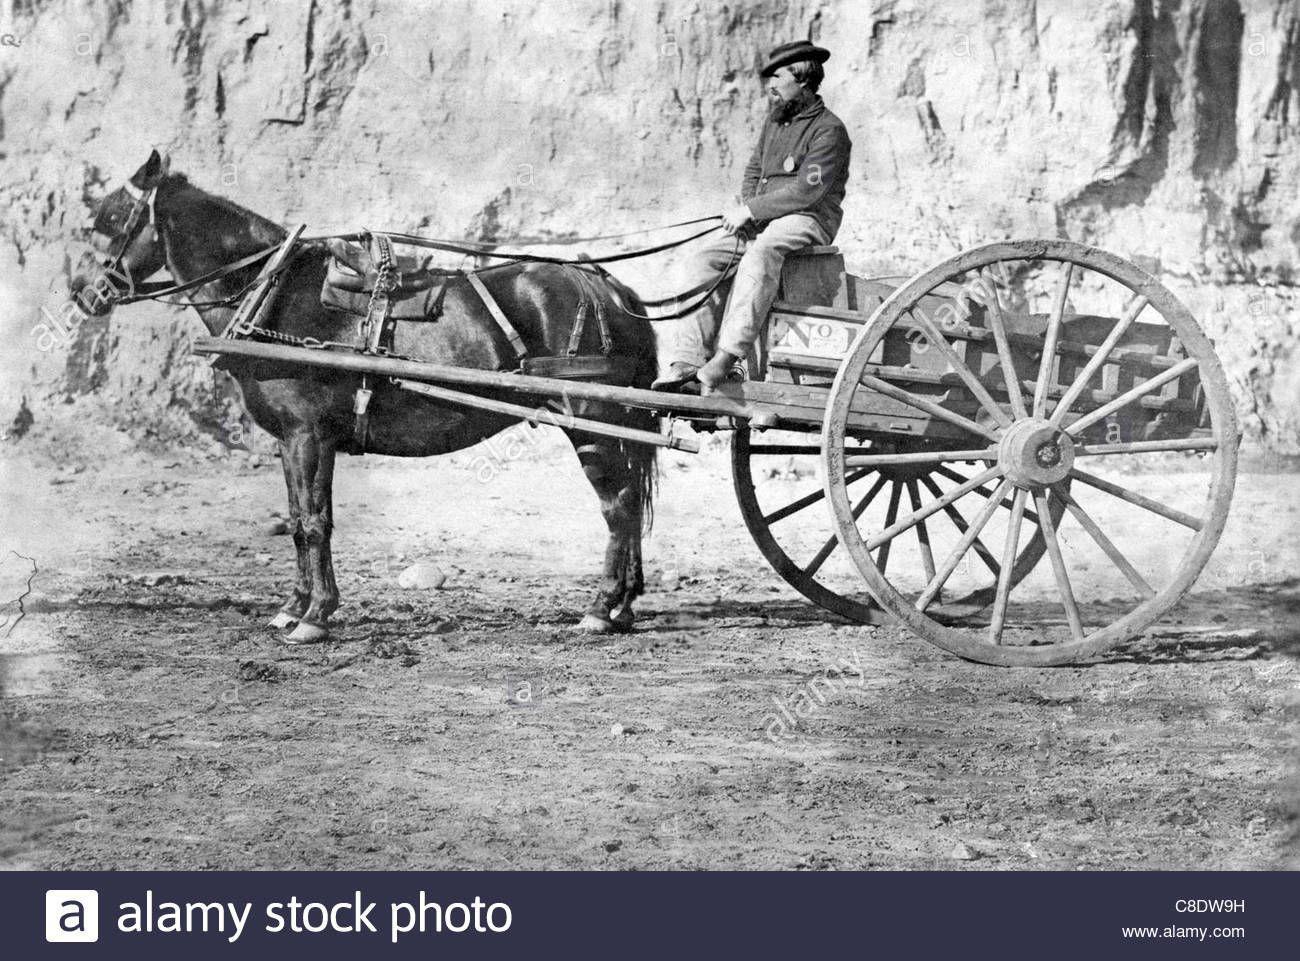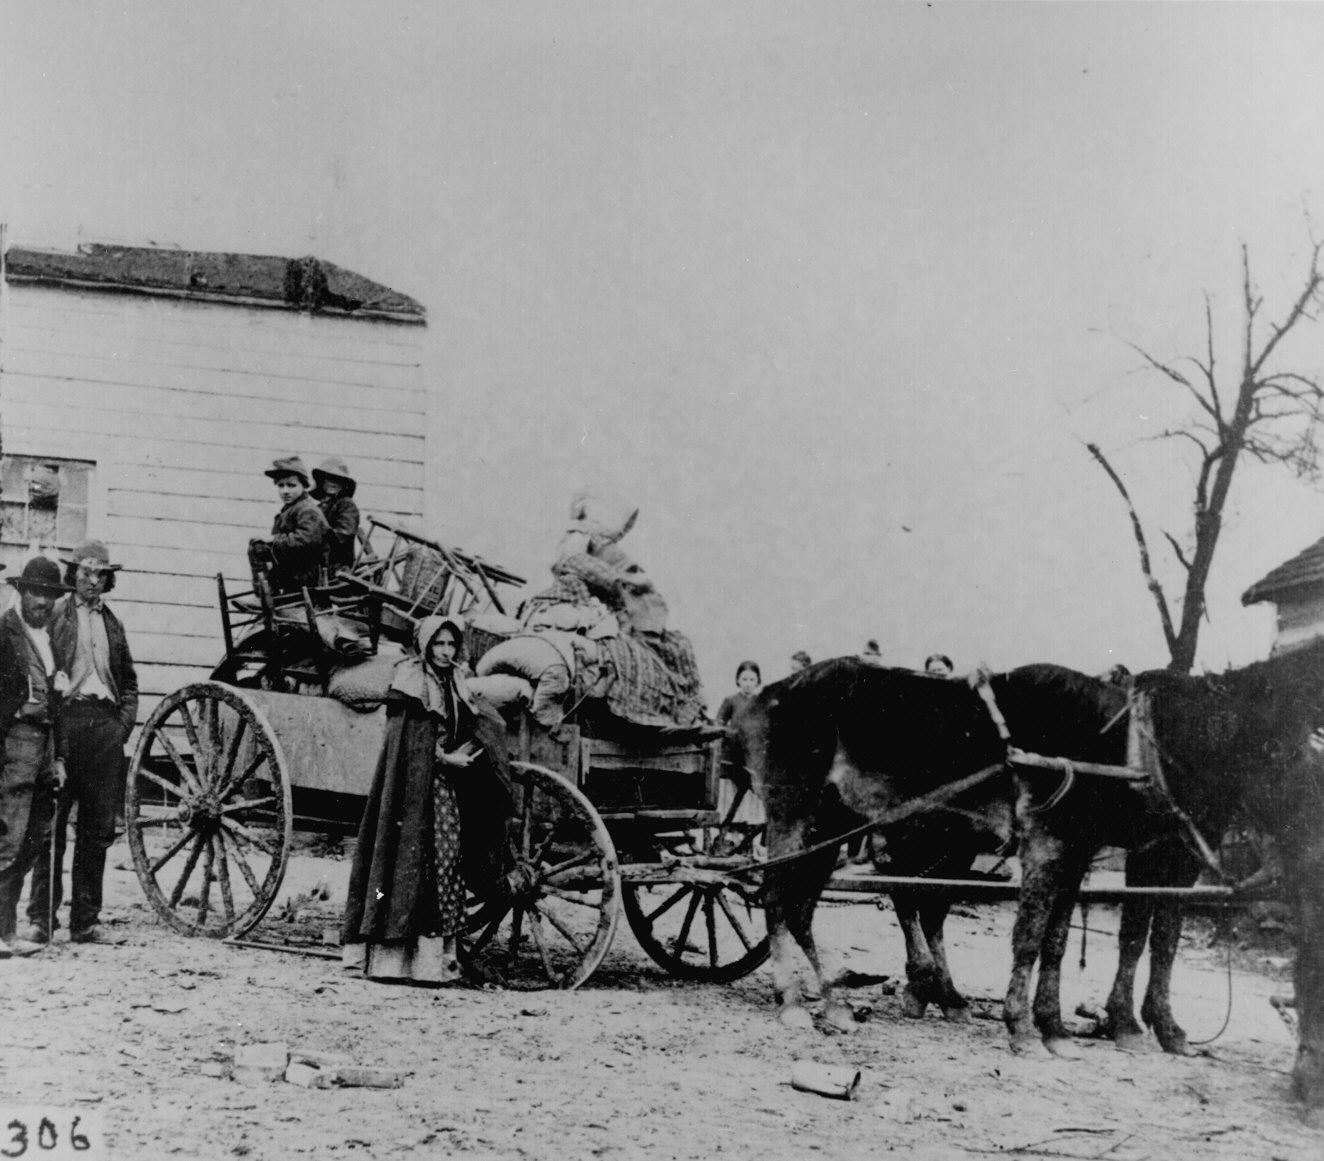The first image is the image on the left, the second image is the image on the right. Evaluate the accuracy of this statement regarding the images: "A man sits on a horse wagon that has only 2 wheels.". Is it true? Answer yes or no. Yes. 